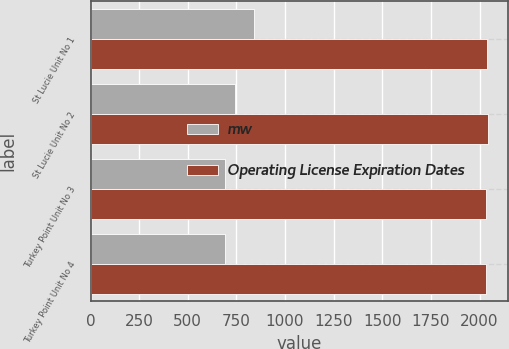Convert chart to OTSL. <chart><loc_0><loc_0><loc_500><loc_500><stacked_bar_chart><ecel><fcel>St Lucie Unit No 1<fcel>St Lucie Unit No 2<fcel>Turkey Point Unit No 3<fcel>Turkey Point Unit No 4<nl><fcel>mw<fcel>839<fcel>745<fcel>693<fcel>693<nl><fcel>Operating License Expiration Dates<fcel>2036<fcel>2043<fcel>2032<fcel>2033<nl></chart> 